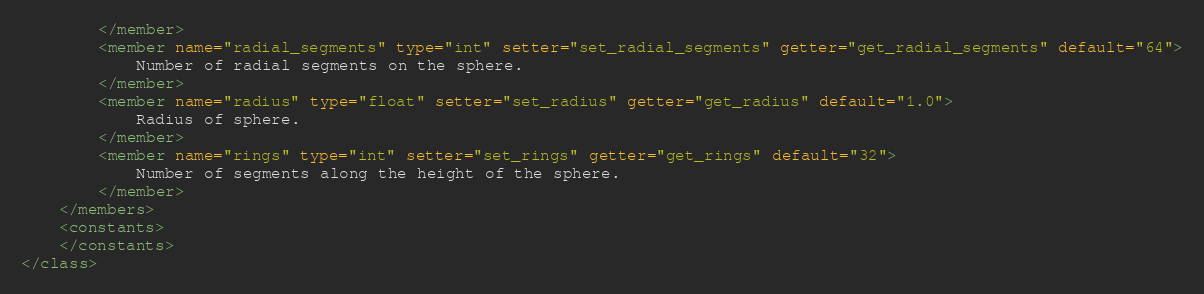<code> <loc_0><loc_0><loc_500><loc_500><_XML_>		</member>
		<member name="radial_segments" type="int" setter="set_radial_segments" getter="get_radial_segments" default="64">
			Number of radial segments on the sphere.
		</member>
		<member name="radius" type="float" setter="set_radius" getter="get_radius" default="1.0">
			Radius of sphere.
		</member>
		<member name="rings" type="int" setter="set_rings" getter="get_rings" default="32">
			Number of segments along the height of the sphere.
		</member>
	</members>
	<constants>
	</constants>
</class>
</code> 